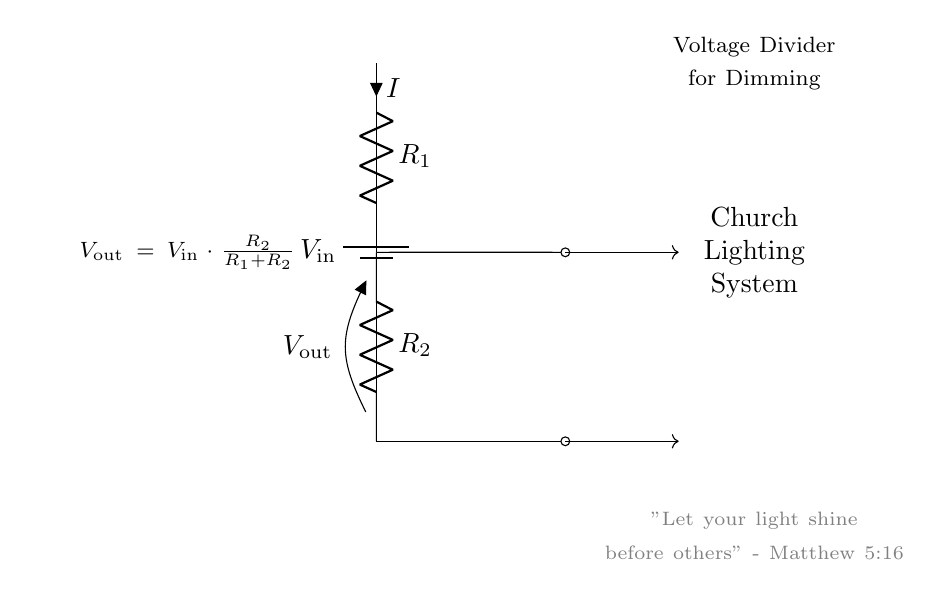What is the input voltage in the circuit? The input voltage is defined as V_in, which is the voltage supplied to the battery in the circuit. This is the voltage that will be divided across the two resistors.
Answer: V_in What is V_out in the circuit? V_out is the output voltage taken across resistor R2, calculated using the formula V_out = V_in * (R2 / (R1 + R2)). This indicates how much voltage is available to the church lighting system.
Answer: V_out What components are present in the circuit? The circuit includes a battery (V_in), two resistors (R1 and R2), and connections leading to the church lighting system. Each component serves a specific function in the voltage division process.
Answer: Battery, R1, R2 What happens to V_out if R2 is increased? If R2 is increased, V_out will also increase since it is directly proportional to the resistance R2 in the voltage divider formula. This means that more voltage will be available for the lighting system when R2 is larger compared to R1.
Answer: V_out increases What is the relationship between R1 and R2 for equal voltage drop across both? For the output voltage to equal the input voltage divided equally, R1 must equal R2. This is because when R1 and R2 are the same, each will take half of the input voltage according to the voltage divider rule.
Answer: R1 = R2 What does the formula V_out = V_in * (R2 / (R1 + R2)) imply about resistor values? This formula shows that V_out is determined by the proportion of R2 relative to the total resistance (R1 + R2). If R2 is significantly larger than R1, V_out approaches V_in, while if R1 is much larger, V_out will be much smaller.
Answer: Proportional relationship What is the role of the resistors in this dimming circuit? The resistors R1 and R2 in the voltage divider play the role of controlling how much voltage drops across each component, effectively determining how bright the church lighting system will be, since lower V_out results in dimmer lights.
Answer: Control brightness 